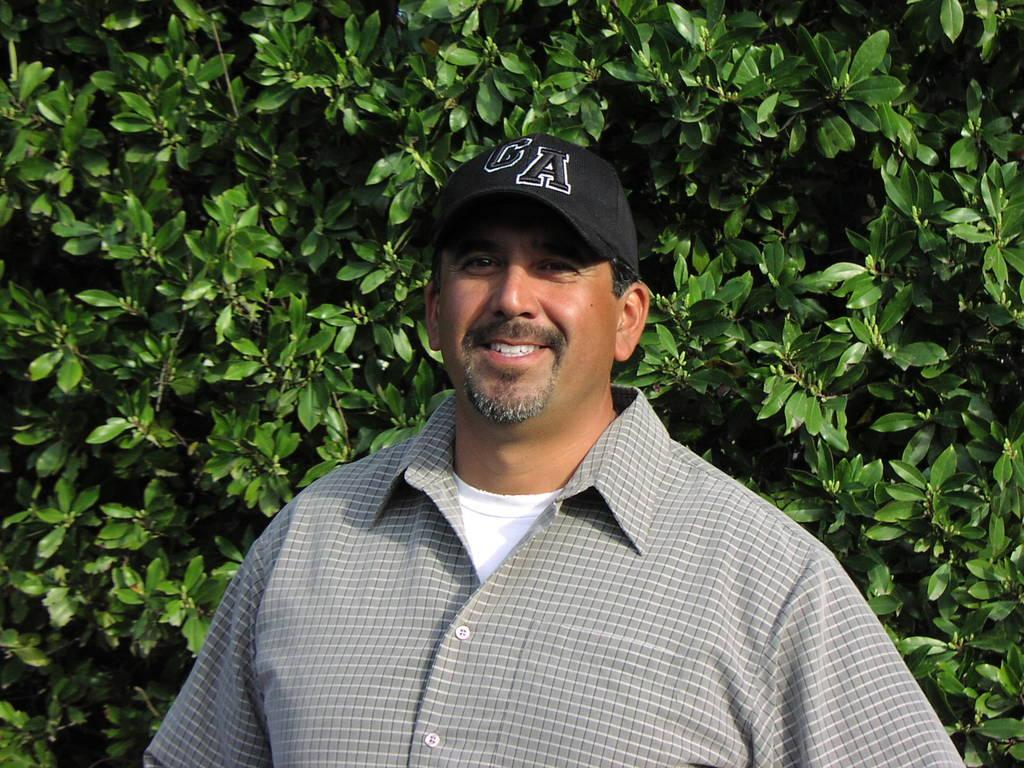What is the main subject of the image? There is a man in the image. What is the man wearing on his upper body? The man is wearing a shirt. What is the man wearing on his head? The man is wearing a cap on his head. What is the man's facial expression in the image? The man is smiling. What is the man doing in the image? The man is giving a pose for the picture. What can be seen in the background of the image? There are leaves visible in the background of the image. Can you see any deer in the image? No, there are no deer present in the image. Is the man in the image showing any signs of fear? No, the man is smiling and giving a pose for the picture, which suggests he is not afraid. 